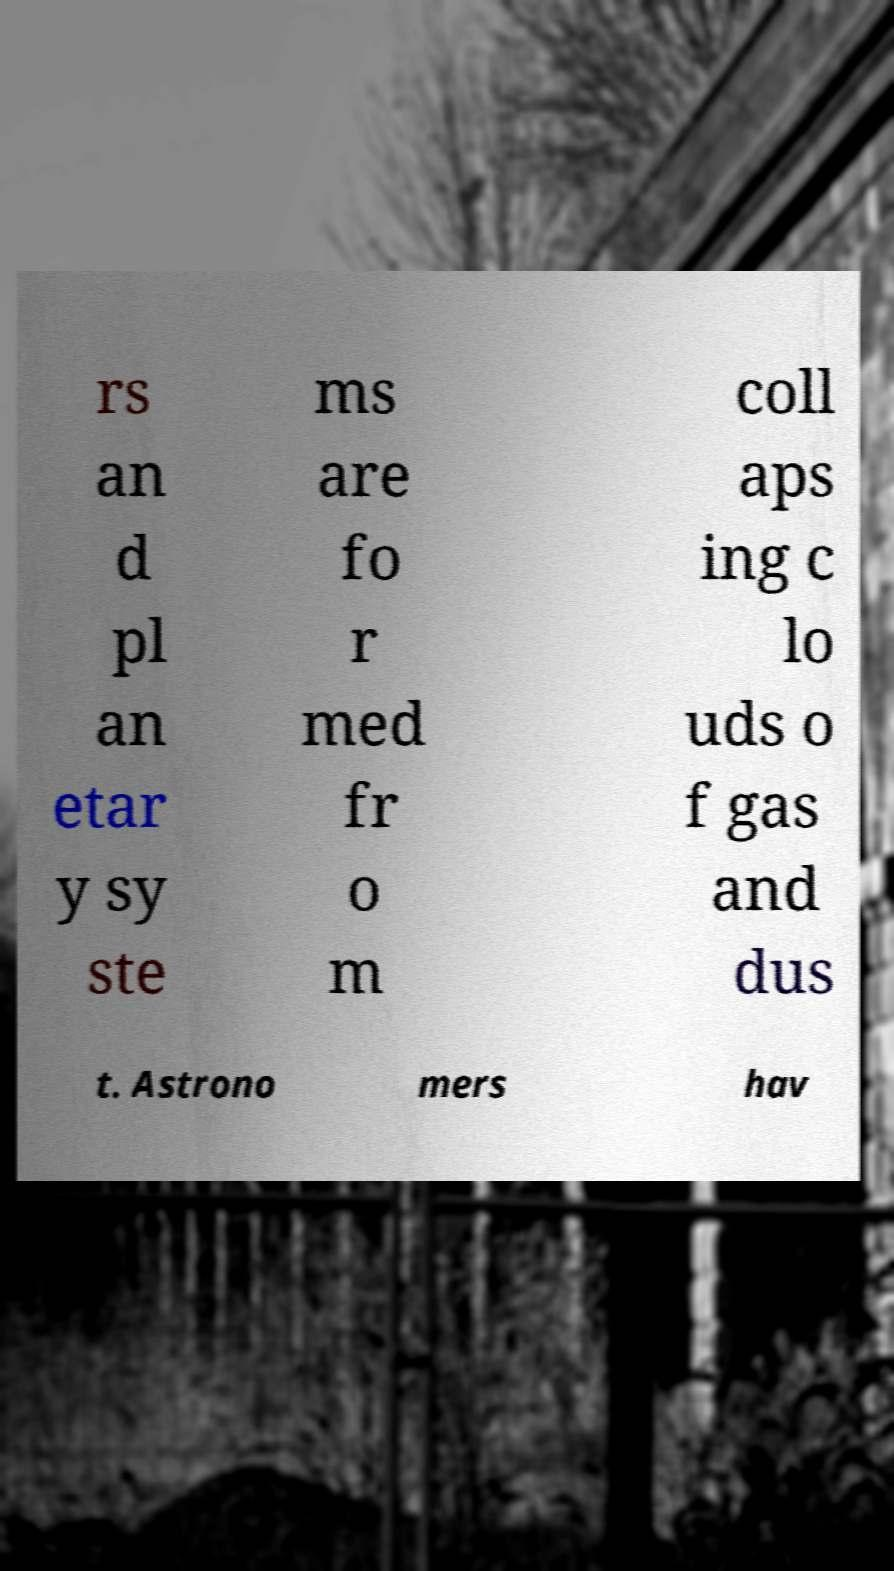Can you read and provide the text displayed in the image?This photo seems to have some interesting text. Can you extract and type it out for me? rs an d pl an etar y sy ste ms are fo r med fr o m coll aps ing c lo uds o f gas and dus t. Astrono mers hav 